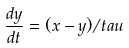Convert formula to latex. <formula><loc_0><loc_0><loc_500><loc_500>\frac { d y } { d t } = ( x - y ) / t a u</formula> 